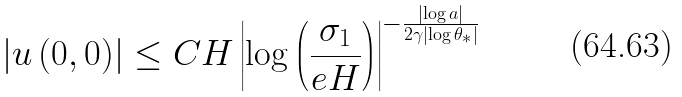<formula> <loc_0><loc_0><loc_500><loc_500>\left | u \left ( 0 , 0 \right ) \right | \leq C H \left | \log \left ( \frac { \sigma _ { 1 } } { e H } \right ) \right | ^ { - \frac { \left | \log a \right | } { 2 \gamma \left | \log \theta _ { \ast } \right | } }</formula> 